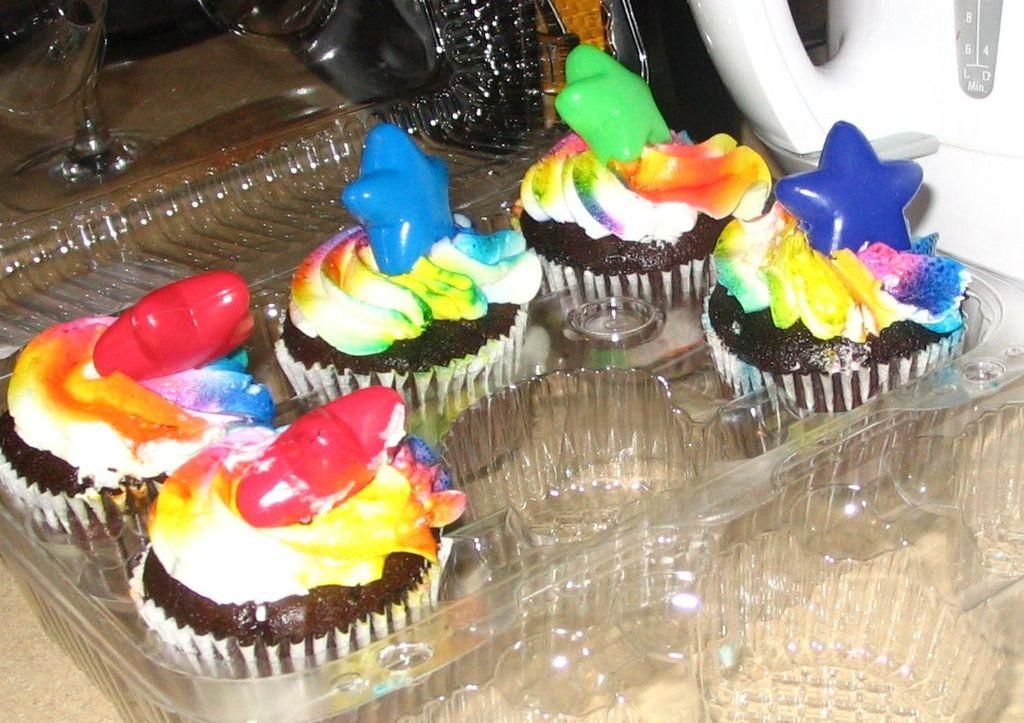What is contained in the plastic box in the image? There is food in a plastic box in the image. Where is the plastic box located? The plastic box is on a table in the center of the image. What can be seen on the right side of the image? There is a white jar on the right side of the image. What is located on the left side of the image? There are glasses on the left side of the image. How does the idea in the image relate to the zipper? There is no mention of an idea or a zipper in the image; the image only contains a plastic box with food, a table, a white jar, and glasses. 